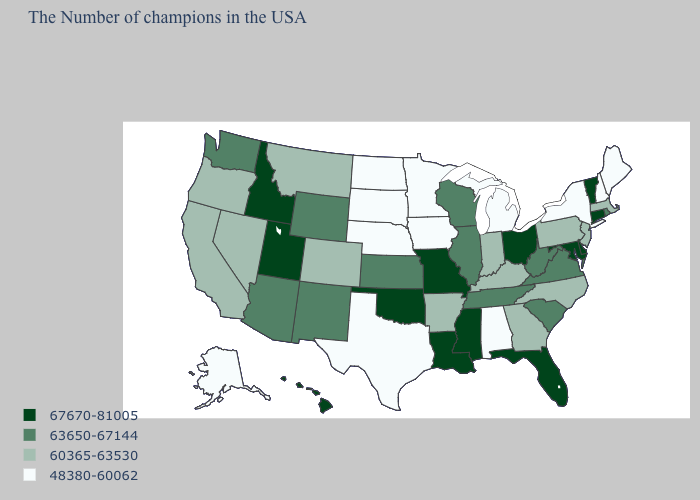Which states have the lowest value in the USA?
Answer briefly. Maine, New Hampshire, New York, Michigan, Alabama, Minnesota, Iowa, Nebraska, Texas, South Dakota, North Dakota, Alaska. Name the states that have a value in the range 67670-81005?
Quick response, please. Vermont, Connecticut, Delaware, Maryland, Ohio, Florida, Mississippi, Louisiana, Missouri, Oklahoma, Utah, Idaho, Hawaii. Which states have the lowest value in the USA?
Keep it brief. Maine, New Hampshire, New York, Michigan, Alabama, Minnesota, Iowa, Nebraska, Texas, South Dakota, North Dakota, Alaska. What is the value of Mississippi?
Answer briefly. 67670-81005. Does the map have missing data?
Short answer required. No. Does the first symbol in the legend represent the smallest category?
Short answer required. No. Does the first symbol in the legend represent the smallest category?
Short answer required. No. Does Georgia have a lower value than Arizona?
Concise answer only. Yes. What is the value of Ohio?
Short answer required. 67670-81005. Name the states that have a value in the range 60365-63530?
Keep it brief. Massachusetts, New Jersey, Pennsylvania, North Carolina, Georgia, Kentucky, Indiana, Arkansas, Colorado, Montana, Nevada, California, Oregon. Is the legend a continuous bar?
Keep it brief. No. What is the value of Rhode Island?
Concise answer only. 63650-67144. What is the value of Kansas?
Be succinct. 63650-67144. What is the value of Nebraska?
Keep it brief. 48380-60062. 